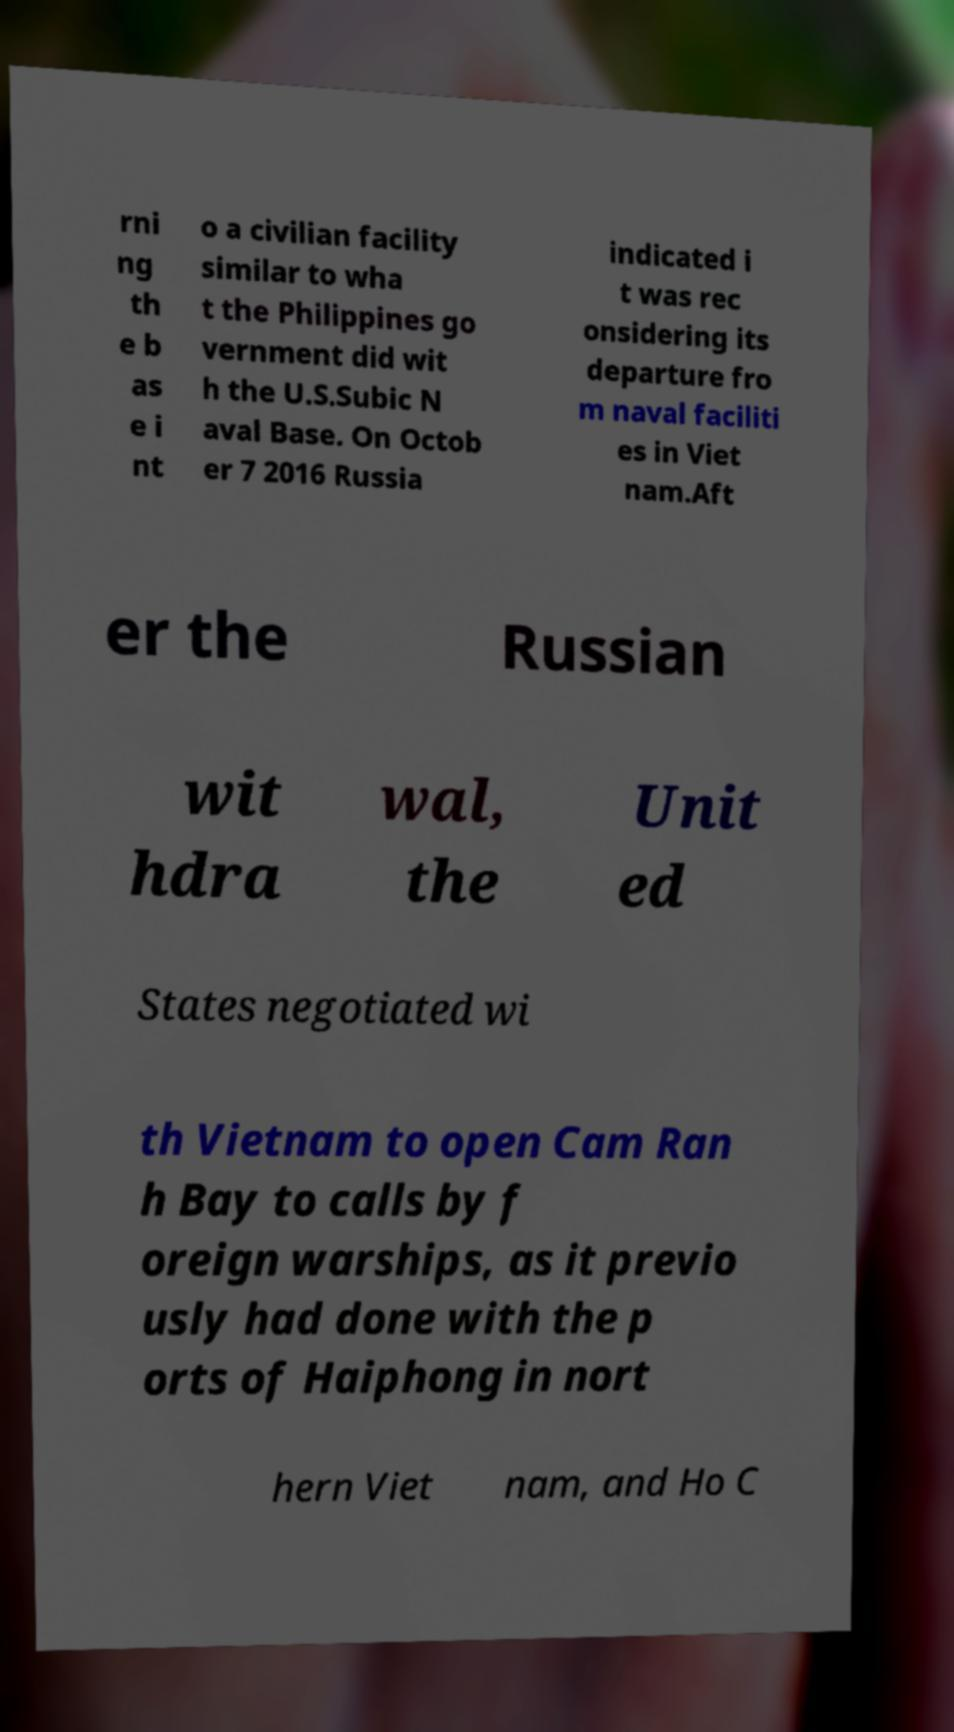Could you assist in decoding the text presented in this image and type it out clearly? rni ng th e b as e i nt o a civilian facility similar to wha t the Philippines go vernment did wit h the U.S.Subic N aval Base. On Octob er 7 2016 Russia indicated i t was rec onsidering its departure fro m naval faciliti es in Viet nam.Aft er the Russian wit hdra wal, the Unit ed States negotiated wi th Vietnam to open Cam Ran h Bay to calls by f oreign warships, as it previo usly had done with the p orts of Haiphong in nort hern Viet nam, and Ho C 